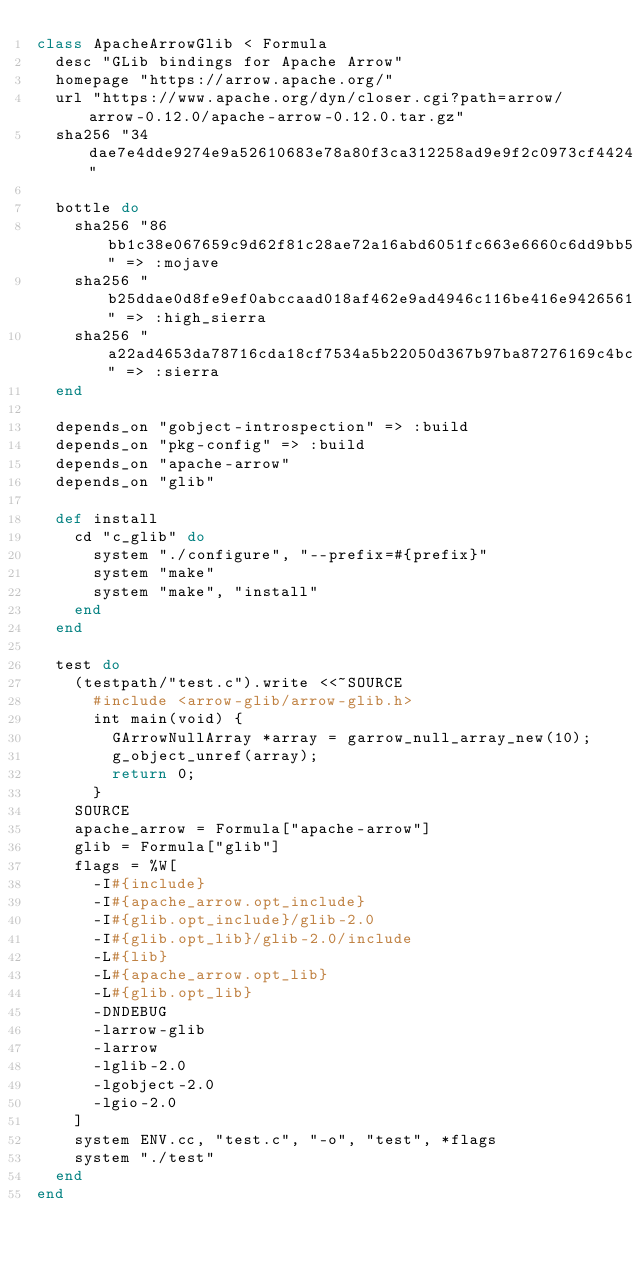<code> <loc_0><loc_0><loc_500><loc_500><_Ruby_>class ApacheArrowGlib < Formula
  desc "GLib bindings for Apache Arrow"
  homepage "https://arrow.apache.org/"
  url "https://www.apache.org/dyn/closer.cgi?path=arrow/arrow-0.12.0/apache-arrow-0.12.0.tar.gz"
  sha256 "34dae7e4dde9274e9a52610683e78a80f3ca312258ad9e9f2c0973cf44247a98"

  bottle do
    sha256 "86bb1c38e067659c9d62f81c28ae72a16abd6051fc663e6660c6dd9bb5f5a43d" => :mojave
    sha256 "b25ddae0d8fe9ef0abccaad018af462e9ad4946c116be416e942656156fa7900" => :high_sierra
    sha256 "a22ad4653da78716cda18cf7534a5b22050d367b97ba87276169c4bc2f27f21e" => :sierra
  end

  depends_on "gobject-introspection" => :build
  depends_on "pkg-config" => :build
  depends_on "apache-arrow"
  depends_on "glib"

  def install
    cd "c_glib" do
      system "./configure", "--prefix=#{prefix}"
      system "make"
      system "make", "install"
    end
  end

  test do
    (testpath/"test.c").write <<~SOURCE
      #include <arrow-glib/arrow-glib.h>
      int main(void) {
        GArrowNullArray *array = garrow_null_array_new(10);
        g_object_unref(array);
        return 0;
      }
    SOURCE
    apache_arrow = Formula["apache-arrow"]
    glib = Formula["glib"]
    flags = %W[
      -I#{include}
      -I#{apache_arrow.opt_include}
      -I#{glib.opt_include}/glib-2.0
      -I#{glib.opt_lib}/glib-2.0/include
      -L#{lib}
      -L#{apache_arrow.opt_lib}
      -L#{glib.opt_lib}
      -DNDEBUG
      -larrow-glib
      -larrow
      -lglib-2.0
      -lgobject-2.0
      -lgio-2.0
    ]
    system ENV.cc, "test.c", "-o", "test", *flags
    system "./test"
  end
end
</code> 